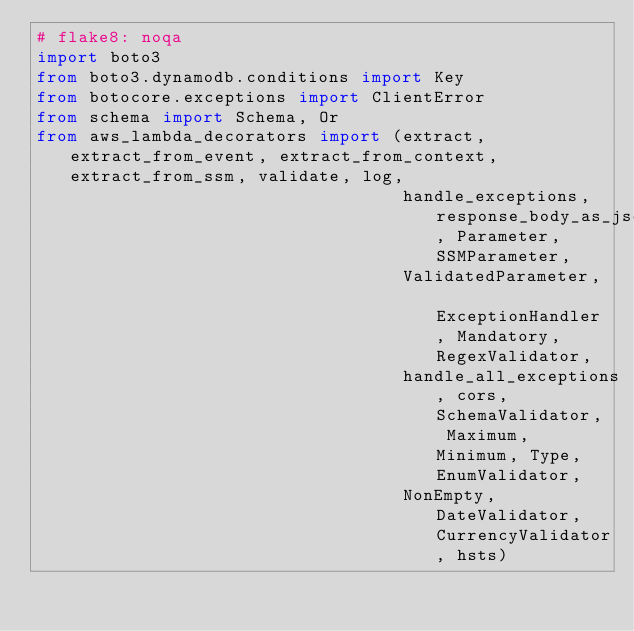<code> <loc_0><loc_0><loc_500><loc_500><_Python_># flake8: noqa
import boto3
from boto3.dynamodb.conditions import Key
from botocore.exceptions import ClientError
from schema import Schema, Or
from aws_lambda_decorators import (extract, extract_from_event, extract_from_context, extract_from_ssm, validate, log,
                                   handle_exceptions, response_body_as_json, Parameter, SSMParameter,
                                   ValidatedParameter, ExceptionHandler, Mandatory, RegexValidator,
                                   handle_all_exceptions, cors, SchemaValidator, Maximum, Minimum, Type, EnumValidator,
                                   NonEmpty, DateValidator, CurrencyValidator, hsts)

</code> 